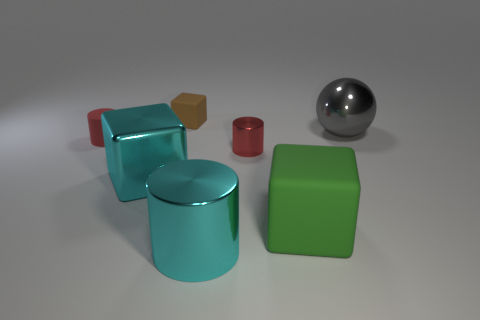There is a large cube that is to the left of the small red cylinder on the right side of the small brown matte object; what color is it?
Your response must be concise. Cyan. Are there an equal number of brown cubes in front of the big green thing and large green things that are left of the large shiny sphere?
Provide a short and direct response. No. Is the big object that is on the left side of the big cyan metal cylinder made of the same material as the tiny block?
Offer a very short reply. No. The matte object that is both to the left of the large green cube and to the right of the tiny matte cylinder is what color?
Your response must be concise. Brown. How many small red metal things are in front of the matte cube in front of the small brown block?
Your answer should be very brief. 0. There is another tiny red object that is the same shape as the red metallic thing; what is its material?
Make the answer very short. Rubber. What color is the tiny metal object?
Your response must be concise. Red. What number of things are large cyan metal things or red cylinders?
Provide a succinct answer. 4. There is a gray object right of the matte cube behind the large metallic ball; what is its shape?
Give a very brief answer. Sphere. How many other things are made of the same material as the sphere?
Provide a short and direct response. 3. 